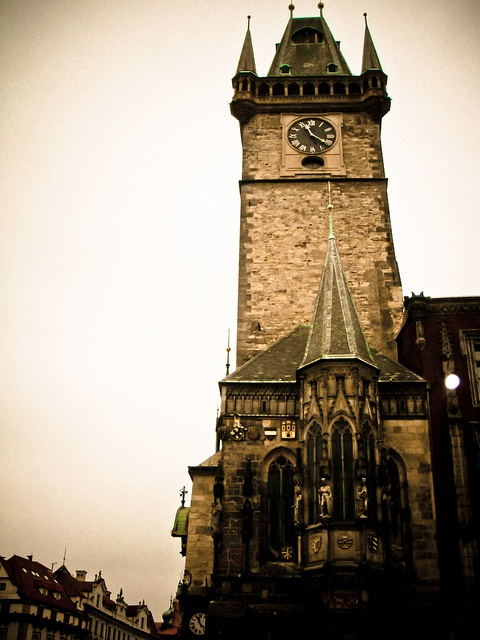Describe the objects in this image and their specific colors. I can see a clock in gray, black, olive, and tan tones in this image. 